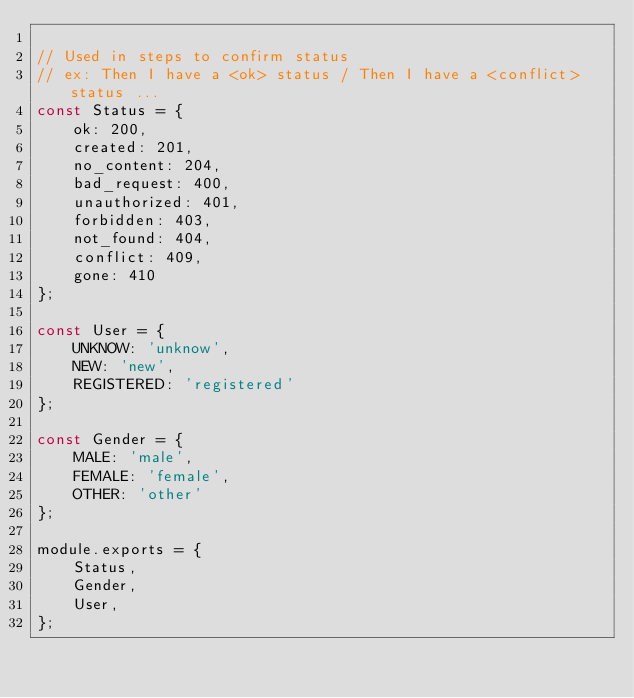Convert code to text. <code><loc_0><loc_0><loc_500><loc_500><_JavaScript_>
// Used in steps to confirm status
// ex: Then I have a <ok> status / Then I have a <conflict> status ...
const Status = {
    ok: 200,
    created: 201,
    no_content: 204,
    bad_request: 400,
    unauthorized: 401,
    forbidden: 403,
    not_found: 404,
    conflict: 409,
    gone: 410
};

const User = {
    UNKNOW: 'unknow',
    NEW: 'new',
    REGISTERED: 'registered'
};

const Gender = {
    MALE: 'male',
    FEMALE: 'female',
    OTHER: 'other'
};

module.exports = {
    Status,
    Gender,
    User,
};</code> 